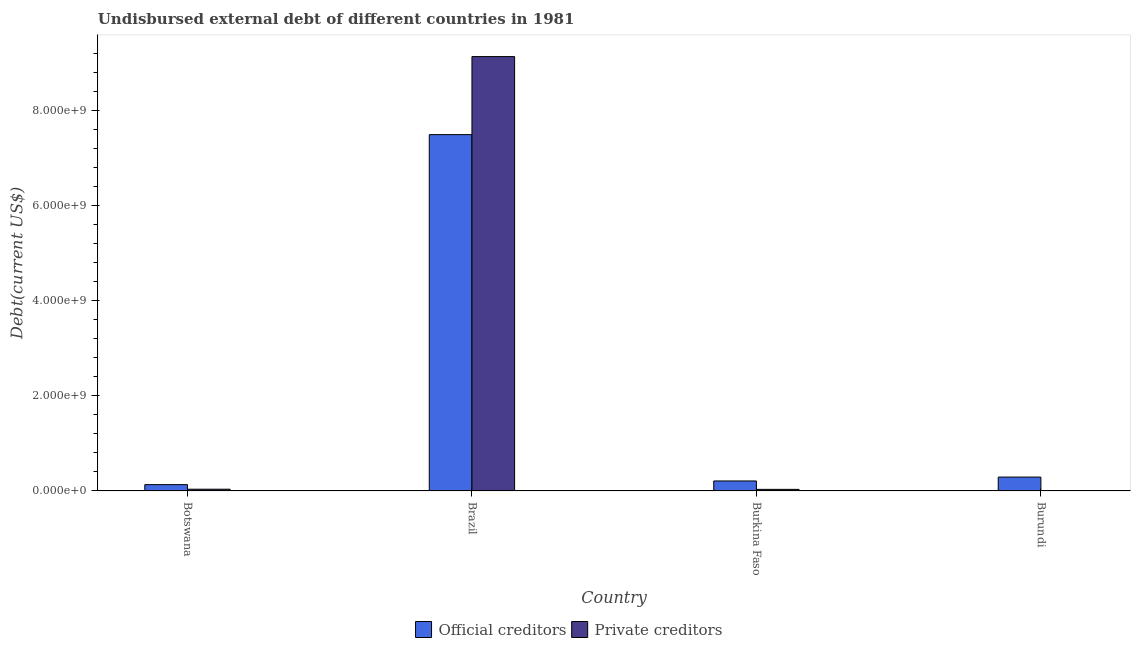How many groups of bars are there?
Offer a very short reply. 4. Are the number of bars on each tick of the X-axis equal?
Provide a short and direct response. Yes. How many bars are there on the 2nd tick from the left?
Offer a very short reply. 2. How many bars are there on the 2nd tick from the right?
Ensure brevity in your answer.  2. What is the label of the 3rd group of bars from the left?
Your response must be concise. Burkina Faso. What is the undisbursed external debt of official creditors in Burkina Faso?
Provide a succinct answer. 2.10e+08. Across all countries, what is the maximum undisbursed external debt of private creditors?
Offer a very short reply. 9.13e+09. Across all countries, what is the minimum undisbursed external debt of official creditors?
Your answer should be compact. 1.33e+08. In which country was the undisbursed external debt of private creditors maximum?
Offer a terse response. Brazil. In which country was the undisbursed external debt of private creditors minimum?
Your answer should be very brief. Burundi. What is the total undisbursed external debt of official creditors in the graph?
Provide a succinct answer. 8.12e+09. What is the difference between the undisbursed external debt of private creditors in Brazil and that in Burkina Faso?
Offer a terse response. 9.10e+09. What is the difference between the undisbursed external debt of private creditors in Burundi and the undisbursed external debt of official creditors in Brazil?
Offer a terse response. -7.48e+09. What is the average undisbursed external debt of private creditors per country?
Ensure brevity in your answer.  2.30e+09. What is the difference between the undisbursed external debt of official creditors and undisbursed external debt of private creditors in Burundi?
Offer a terse response. 2.84e+08. In how many countries, is the undisbursed external debt of private creditors greater than 1600000000 US$?
Ensure brevity in your answer.  1. What is the ratio of the undisbursed external debt of private creditors in Botswana to that in Brazil?
Give a very brief answer. 0. What is the difference between the highest and the second highest undisbursed external debt of private creditors?
Keep it short and to the point. 9.09e+09. What is the difference between the highest and the lowest undisbursed external debt of official creditors?
Provide a succinct answer. 7.36e+09. Is the sum of the undisbursed external debt of private creditors in Botswana and Burkina Faso greater than the maximum undisbursed external debt of official creditors across all countries?
Keep it short and to the point. No. What does the 1st bar from the left in Burundi represents?
Ensure brevity in your answer.  Official creditors. What does the 2nd bar from the right in Burkina Faso represents?
Provide a short and direct response. Official creditors. How many bars are there?
Your answer should be compact. 8. How many countries are there in the graph?
Keep it short and to the point. 4. What is the difference between two consecutive major ticks on the Y-axis?
Your answer should be compact. 2.00e+09. Does the graph contain any zero values?
Offer a very short reply. No. Does the graph contain grids?
Offer a terse response. No. Where does the legend appear in the graph?
Your answer should be compact. Bottom center. How many legend labels are there?
Your answer should be very brief. 2. What is the title of the graph?
Provide a succinct answer. Undisbursed external debt of different countries in 1981. Does "Public funds" appear as one of the legend labels in the graph?
Give a very brief answer. No. What is the label or title of the Y-axis?
Ensure brevity in your answer.  Debt(current US$). What is the Debt(current US$) in Official creditors in Botswana?
Keep it short and to the point. 1.33e+08. What is the Debt(current US$) of Private creditors in Botswana?
Make the answer very short. 3.62e+07. What is the Debt(current US$) of Official creditors in Brazil?
Make the answer very short. 7.49e+09. What is the Debt(current US$) in Private creditors in Brazil?
Offer a terse response. 9.13e+09. What is the Debt(current US$) of Official creditors in Burkina Faso?
Your response must be concise. 2.10e+08. What is the Debt(current US$) of Private creditors in Burkina Faso?
Your response must be concise. 3.31e+07. What is the Debt(current US$) of Official creditors in Burundi?
Make the answer very short. 2.91e+08. What is the Debt(current US$) in Private creditors in Burundi?
Offer a very short reply. 7.10e+06. Across all countries, what is the maximum Debt(current US$) of Official creditors?
Keep it short and to the point. 7.49e+09. Across all countries, what is the maximum Debt(current US$) of Private creditors?
Provide a short and direct response. 9.13e+09. Across all countries, what is the minimum Debt(current US$) in Official creditors?
Ensure brevity in your answer.  1.33e+08. Across all countries, what is the minimum Debt(current US$) of Private creditors?
Your answer should be very brief. 7.10e+06. What is the total Debt(current US$) of Official creditors in the graph?
Keep it short and to the point. 8.12e+09. What is the total Debt(current US$) of Private creditors in the graph?
Provide a succinct answer. 9.21e+09. What is the difference between the Debt(current US$) of Official creditors in Botswana and that in Brazil?
Offer a terse response. -7.36e+09. What is the difference between the Debt(current US$) of Private creditors in Botswana and that in Brazil?
Make the answer very short. -9.09e+09. What is the difference between the Debt(current US$) of Official creditors in Botswana and that in Burkina Faso?
Your response must be concise. -7.71e+07. What is the difference between the Debt(current US$) in Private creditors in Botswana and that in Burkina Faso?
Your answer should be compact. 3.13e+06. What is the difference between the Debt(current US$) of Official creditors in Botswana and that in Burundi?
Your answer should be compact. -1.59e+08. What is the difference between the Debt(current US$) in Private creditors in Botswana and that in Burundi?
Give a very brief answer. 2.91e+07. What is the difference between the Debt(current US$) in Official creditors in Brazil and that in Burkina Faso?
Offer a very short reply. 7.28e+09. What is the difference between the Debt(current US$) in Private creditors in Brazil and that in Burkina Faso?
Make the answer very short. 9.10e+09. What is the difference between the Debt(current US$) of Official creditors in Brazil and that in Burundi?
Your response must be concise. 7.20e+09. What is the difference between the Debt(current US$) in Private creditors in Brazil and that in Burundi?
Offer a terse response. 9.12e+09. What is the difference between the Debt(current US$) in Official creditors in Burkina Faso and that in Burundi?
Provide a short and direct response. -8.17e+07. What is the difference between the Debt(current US$) of Private creditors in Burkina Faso and that in Burundi?
Your answer should be compact. 2.60e+07. What is the difference between the Debt(current US$) in Official creditors in Botswana and the Debt(current US$) in Private creditors in Brazil?
Your answer should be very brief. -9.00e+09. What is the difference between the Debt(current US$) in Official creditors in Botswana and the Debt(current US$) in Private creditors in Burkina Faso?
Give a very brief answer. 9.95e+07. What is the difference between the Debt(current US$) in Official creditors in Botswana and the Debt(current US$) in Private creditors in Burundi?
Offer a very short reply. 1.26e+08. What is the difference between the Debt(current US$) of Official creditors in Brazil and the Debt(current US$) of Private creditors in Burkina Faso?
Provide a succinct answer. 7.46e+09. What is the difference between the Debt(current US$) in Official creditors in Brazil and the Debt(current US$) in Private creditors in Burundi?
Your answer should be compact. 7.48e+09. What is the difference between the Debt(current US$) of Official creditors in Burkina Faso and the Debt(current US$) of Private creditors in Burundi?
Offer a very short reply. 2.03e+08. What is the average Debt(current US$) of Official creditors per country?
Your answer should be very brief. 2.03e+09. What is the average Debt(current US$) in Private creditors per country?
Your answer should be very brief. 2.30e+09. What is the difference between the Debt(current US$) in Official creditors and Debt(current US$) in Private creditors in Botswana?
Your response must be concise. 9.64e+07. What is the difference between the Debt(current US$) of Official creditors and Debt(current US$) of Private creditors in Brazil?
Give a very brief answer. -1.64e+09. What is the difference between the Debt(current US$) in Official creditors and Debt(current US$) in Private creditors in Burkina Faso?
Give a very brief answer. 1.77e+08. What is the difference between the Debt(current US$) of Official creditors and Debt(current US$) of Private creditors in Burundi?
Ensure brevity in your answer.  2.84e+08. What is the ratio of the Debt(current US$) of Official creditors in Botswana to that in Brazil?
Your answer should be compact. 0.02. What is the ratio of the Debt(current US$) of Private creditors in Botswana to that in Brazil?
Provide a succinct answer. 0. What is the ratio of the Debt(current US$) of Official creditors in Botswana to that in Burkina Faso?
Keep it short and to the point. 0.63. What is the ratio of the Debt(current US$) in Private creditors in Botswana to that in Burkina Faso?
Provide a succinct answer. 1.09. What is the ratio of the Debt(current US$) of Official creditors in Botswana to that in Burundi?
Give a very brief answer. 0.46. What is the ratio of the Debt(current US$) in Private creditors in Botswana to that in Burundi?
Ensure brevity in your answer.  5.11. What is the ratio of the Debt(current US$) in Official creditors in Brazil to that in Burkina Faso?
Offer a terse response. 35.71. What is the ratio of the Debt(current US$) of Private creditors in Brazil to that in Burkina Faso?
Offer a terse response. 275.69. What is the ratio of the Debt(current US$) of Official creditors in Brazil to that in Burundi?
Your answer should be very brief. 25.7. What is the ratio of the Debt(current US$) of Private creditors in Brazil to that in Burundi?
Provide a succinct answer. 1286.11. What is the ratio of the Debt(current US$) in Official creditors in Burkina Faso to that in Burundi?
Ensure brevity in your answer.  0.72. What is the ratio of the Debt(current US$) in Private creditors in Burkina Faso to that in Burundi?
Make the answer very short. 4.67. What is the difference between the highest and the second highest Debt(current US$) in Official creditors?
Keep it short and to the point. 7.20e+09. What is the difference between the highest and the second highest Debt(current US$) in Private creditors?
Give a very brief answer. 9.09e+09. What is the difference between the highest and the lowest Debt(current US$) in Official creditors?
Make the answer very short. 7.36e+09. What is the difference between the highest and the lowest Debt(current US$) in Private creditors?
Make the answer very short. 9.12e+09. 